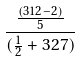Convert formula to latex. <formula><loc_0><loc_0><loc_500><loc_500>\frac { \frac { ( 3 1 2 - 2 ) } { 5 } } { ( \frac { 1 } { 2 } + 3 2 7 ) }</formula> 